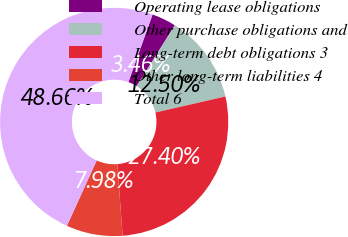Convert chart to OTSL. <chart><loc_0><loc_0><loc_500><loc_500><pie_chart><fcel>Operating lease obligations<fcel>Other purchase obligations and<fcel>Long-term debt obligations 3<fcel>Other long-term liabilities 4<fcel>Total 6<nl><fcel>3.46%<fcel>12.5%<fcel>27.4%<fcel>7.98%<fcel>48.66%<nl></chart> 